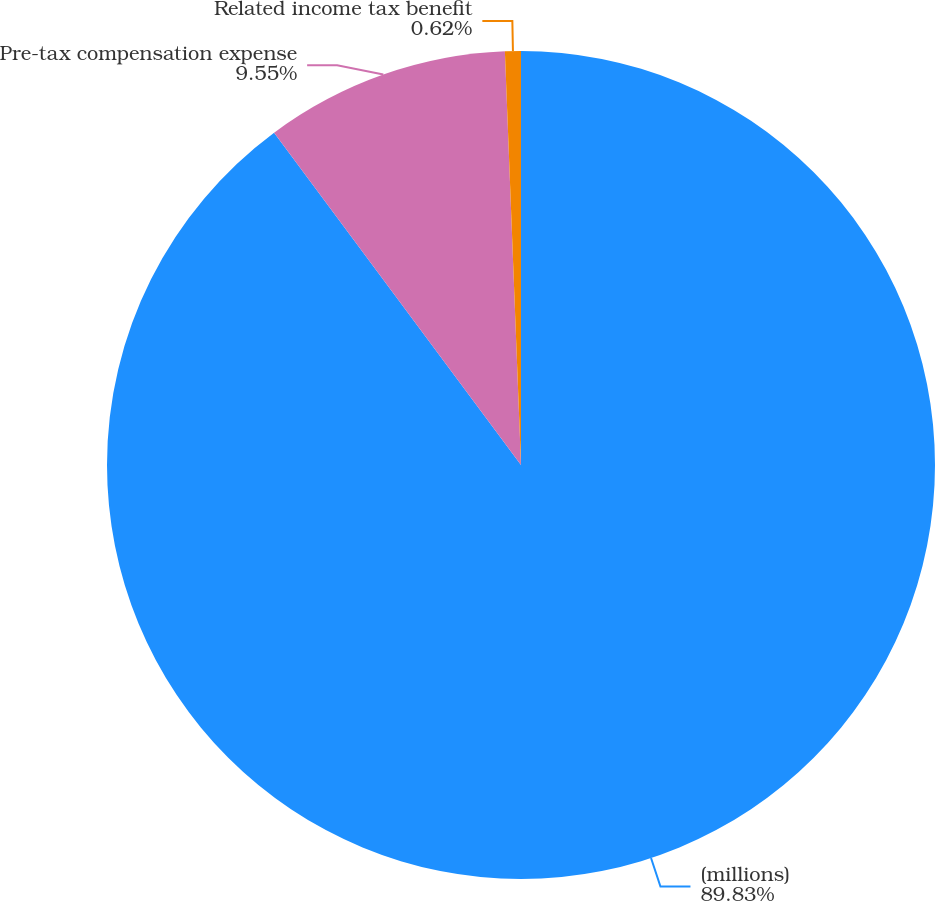Convert chart to OTSL. <chart><loc_0><loc_0><loc_500><loc_500><pie_chart><fcel>(millions)<fcel>Pre-tax compensation expense<fcel>Related income tax benefit<nl><fcel>89.83%<fcel>9.55%<fcel>0.62%<nl></chart> 